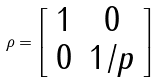<formula> <loc_0><loc_0><loc_500><loc_500>\rho = \left [ \begin{array} { c c } 1 & 0 \\ 0 & 1 / p \end{array} \right ]</formula> 